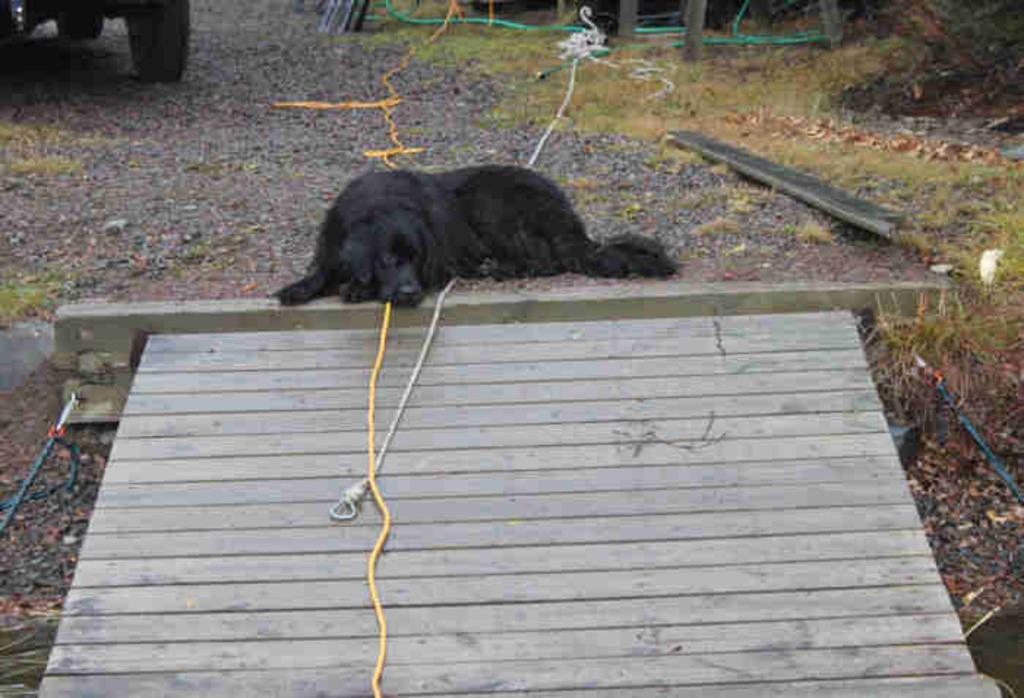Please provide a concise description of this image. In this image we can see a dog is lying on the ground and there are ropes and wooden platform. In the background on the left side we can see wheels of a vehicle's and there are stones and objects on the ground. 